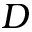Convert formula to latex. <formula><loc_0><loc_0><loc_500><loc_500>D</formula> 